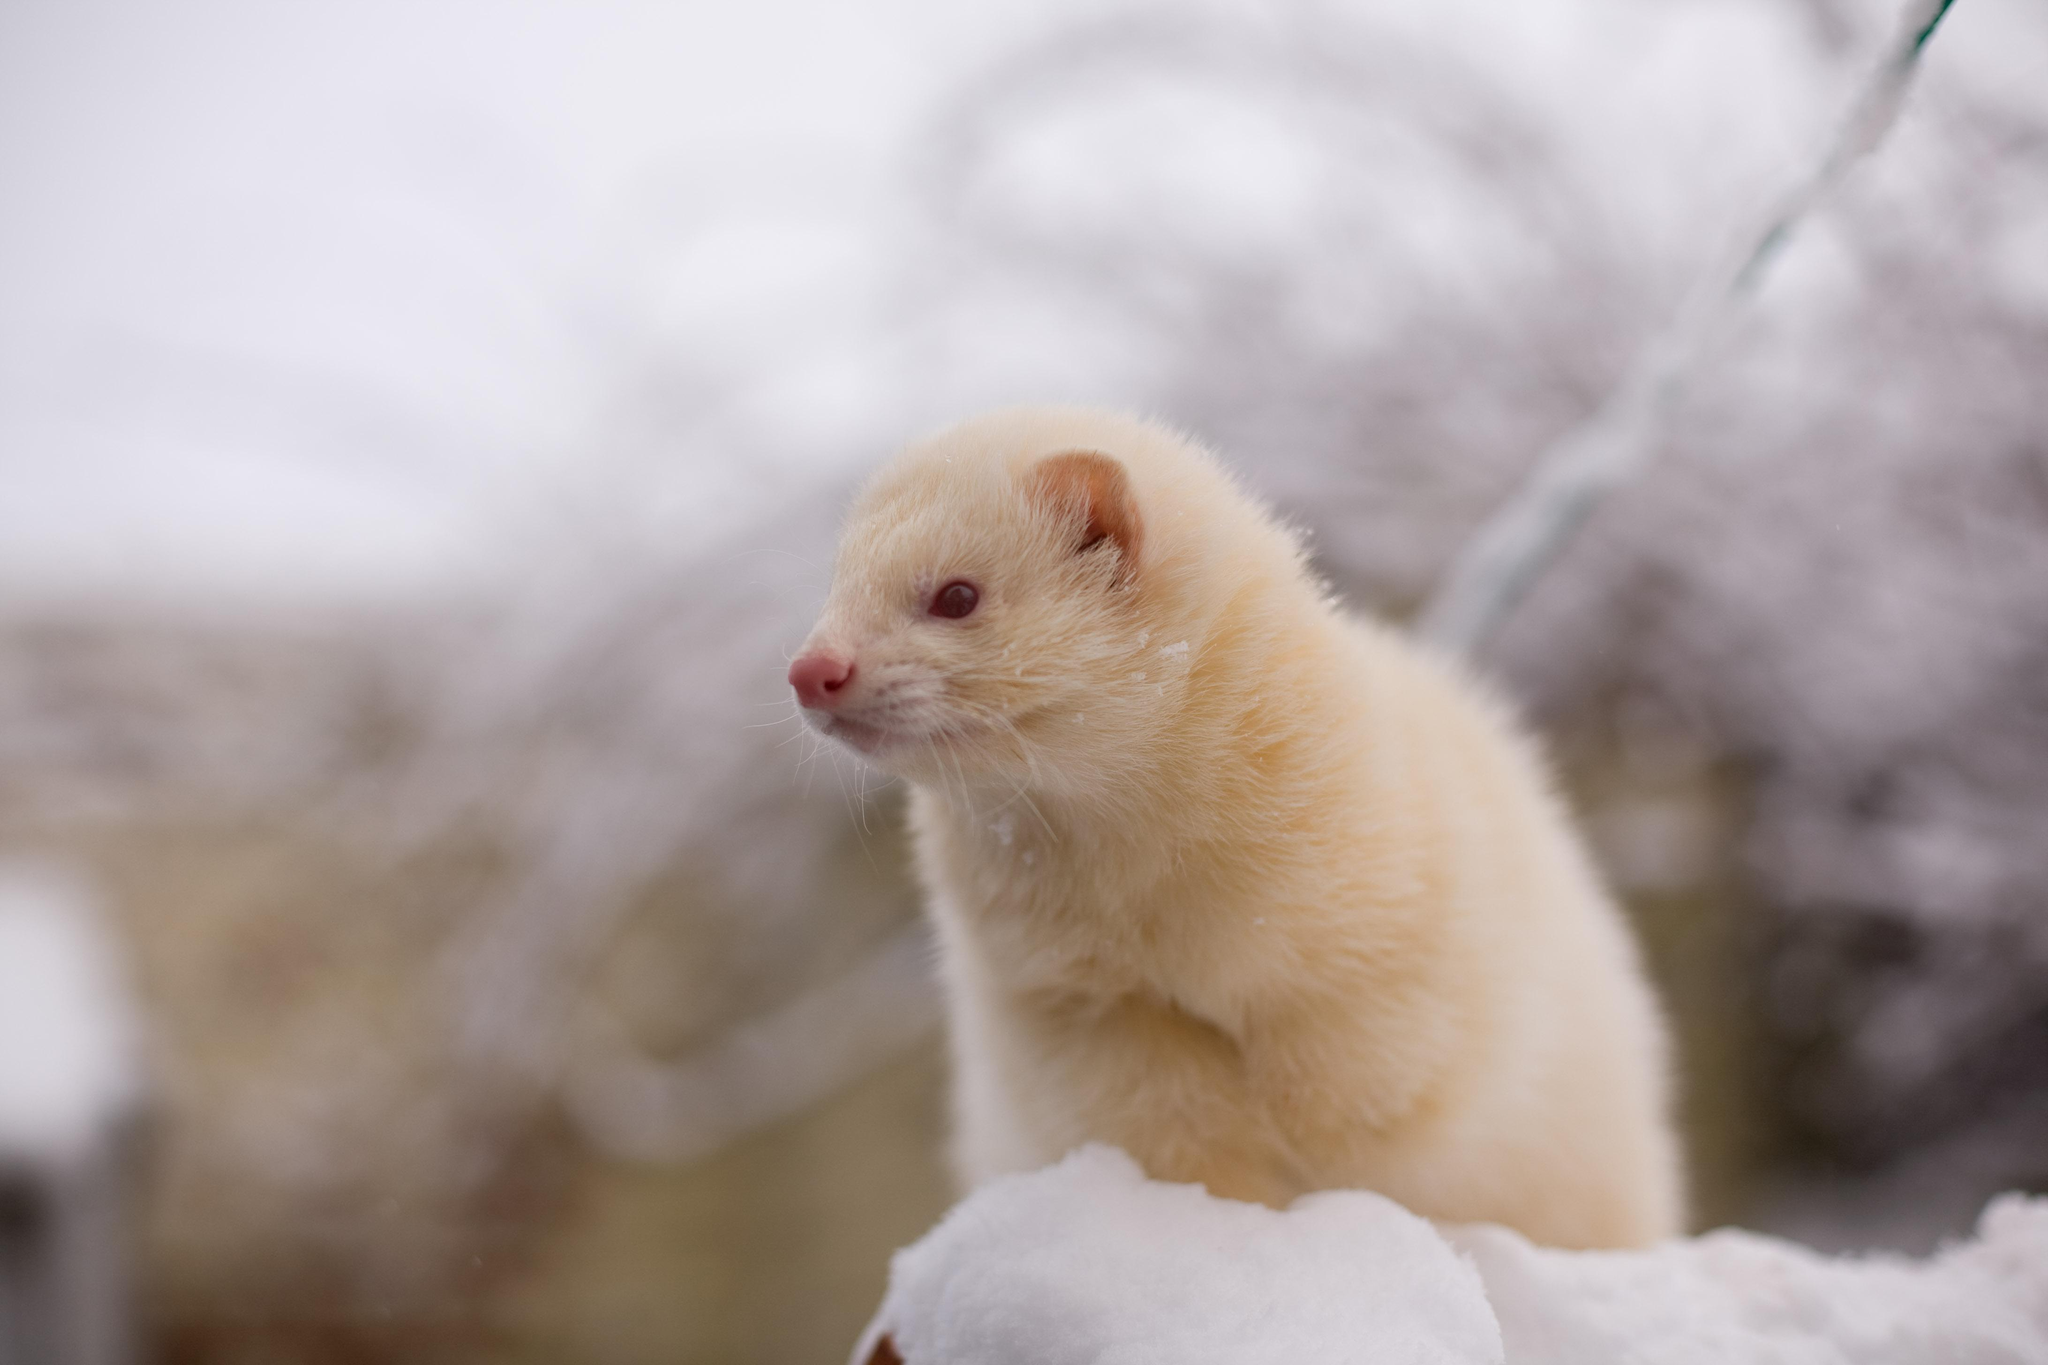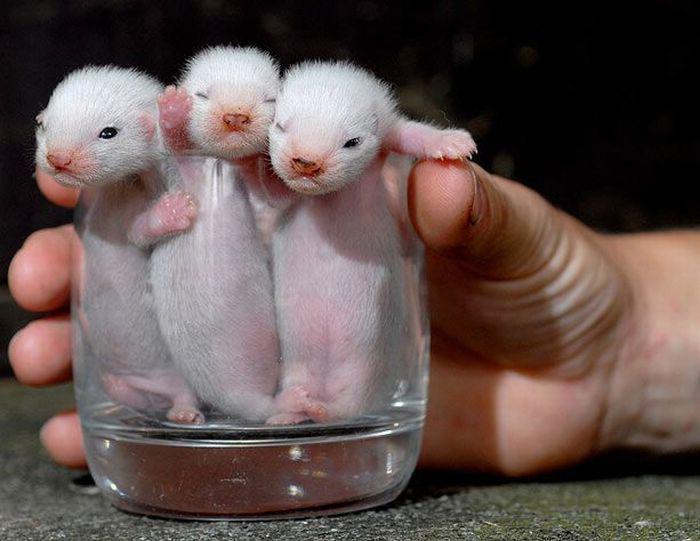The first image is the image on the left, the second image is the image on the right. Examine the images to the left and right. Is the description "There is exactly two ferrets." accurate? Answer yes or no. No. 